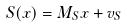<formula> <loc_0><loc_0><loc_500><loc_500>S ( x ) = M _ { S } x + v _ { S }</formula> 